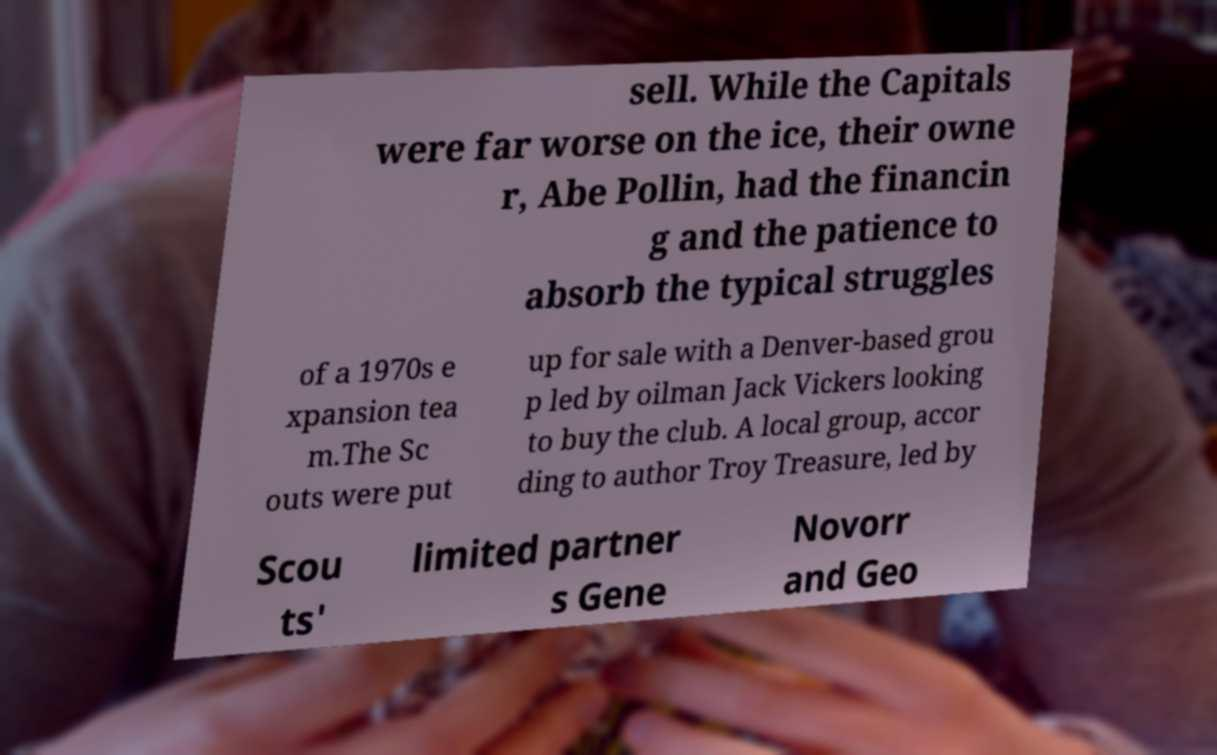Could you extract and type out the text from this image? sell. While the Capitals were far worse on the ice, their owne r, Abe Pollin, had the financin g and the patience to absorb the typical struggles of a 1970s e xpansion tea m.The Sc outs were put up for sale with a Denver-based grou p led by oilman Jack Vickers looking to buy the club. A local group, accor ding to author Troy Treasure, led by Scou ts' limited partner s Gene Novorr and Geo 